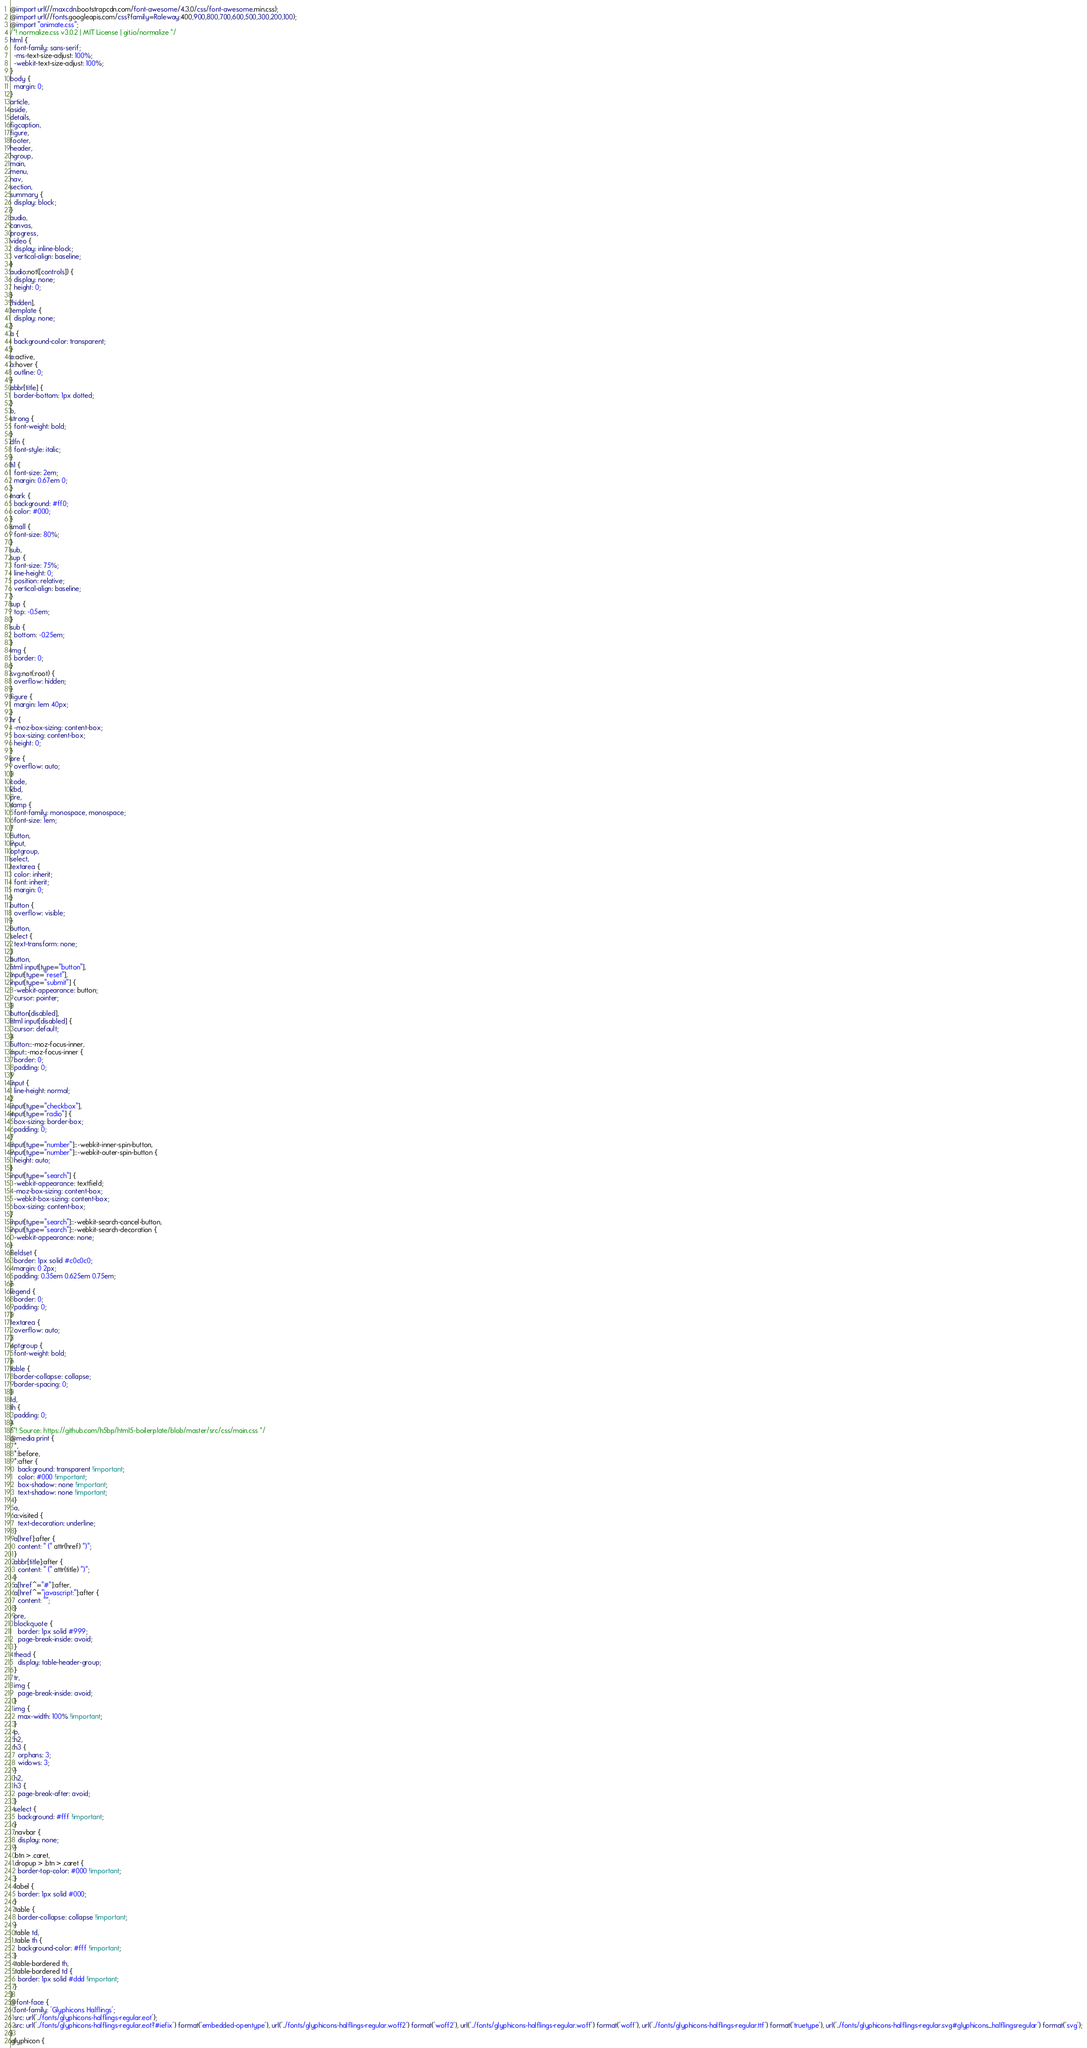Convert code to text. <code><loc_0><loc_0><loc_500><loc_500><_CSS_>@import url(//maxcdn.bootstrapcdn.com/font-awesome/4.3.0/css/font-awesome.min.css);
@import url(//fonts.googleapis.com/css?family=Raleway:400,900,800,700,600,500,300,200,100);
@import "animate.css";
/*! normalize.css v3.0.2 | MIT License | git.io/normalize */
html {
  font-family: sans-serif;
  -ms-text-size-adjust: 100%;
  -webkit-text-size-adjust: 100%;
}
body {
  margin: 0;
}
article,
aside,
details,
figcaption,
figure,
footer,
header,
hgroup,
main,
menu,
nav,
section,
summary {
  display: block;
}
audio,
canvas,
progress,
video {
  display: inline-block;
  vertical-align: baseline;
}
audio:not([controls]) {
  display: none;
  height: 0;
}
[hidden],
template {
  display: none;
}
a {
  background-color: transparent;
}
a:active,
a:hover {
  outline: 0;
}
abbr[title] {
  border-bottom: 1px dotted;
}
b,
strong {
  font-weight: bold;
}
dfn {
  font-style: italic;
}
h1 {
  font-size: 2em;
  margin: 0.67em 0;
}
mark {
  background: #ff0;
  color: #000;
}
small {
  font-size: 80%;
}
sub,
sup {
  font-size: 75%;
  line-height: 0;
  position: relative;
  vertical-align: baseline;
}
sup {
  top: -0.5em;
}
sub {
  bottom: -0.25em;
}
img {
  border: 0;
}
svg:not(:root) {
  overflow: hidden;
}
figure {
  margin: 1em 40px;
}
hr {
  -moz-box-sizing: content-box;
  box-sizing: content-box;
  height: 0;
}
pre {
  overflow: auto;
}
code,
kbd,
pre,
samp {
  font-family: monospace, monospace;
  font-size: 1em;
}
button,
input,
optgroup,
select,
textarea {
  color: inherit;
  font: inherit;
  margin: 0;
}
button {
  overflow: visible;
}
button,
select {
  text-transform: none;
}
button,
html input[type="button"],
input[type="reset"],
input[type="submit"] {
  -webkit-appearance: button;
  cursor: pointer;
}
button[disabled],
html input[disabled] {
  cursor: default;
}
button::-moz-focus-inner,
input::-moz-focus-inner {
  border: 0;
  padding: 0;
}
input {
  line-height: normal;
}
input[type="checkbox"],
input[type="radio"] {
  box-sizing: border-box;
  padding: 0;
}
input[type="number"]::-webkit-inner-spin-button,
input[type="number"]::-webkit-outer-spin-button {
  height: auto;
}
input[type="search"] {
  -webkit-appearance: textfield;
  -moz-box-sizing: content-box;
  -webkit-box-sizing: content-box;
  box-sizing: content-box;
}
input[type="search"]::-webkit-search-cancel-button,
input[type="search"]::-webkit-search-decoration {
  -webkit-appearance: none;
}
fieldset {
  border: 1px solid #c0c0c0;
  margin: 0 2px;
  padding: 0.35em 0.625em 0.75em;
}
legend {
  border: 0;
  padding: 0;
}
textarea {
  overflow: auto;
}
optgroup {
  font-weight: bold;
}
table {
  border-collapse: collapse;
  border-spacing: 0;
}
td,
th {
  padding: 0;
}
/*! Source: https://github.com/h5bp/html5-boilerplate/blob/master/src/css/main.css */
@media print {
  *,
  *:before,
  *:after {
    background: transparent !important;
    color: #000 !important;
    box-shadow: none !important;
    text-shadow: none !important;
  }
  a,
  a:visited {
    text-decoration: underline;
  }
  a[href]:after {
    content: " (" attr(href) ")";
  }
  abbr[title]:after {
    content: " (" attr(title) ")";
  }
  a[href^="#"]:after,
  a[href^="javascript:"]:after {
    content: "";
  }
  pre,
  blockquote {
    border: 1px solid #999;
    page-break-inside: avoid;
  }
  thead {
    display: table-header-group;
  }
  tr,
  img {
    page-break-inside: avoid;
  }
  img {
    max-width: 100% !important;
  }
  p,
  h2,
  h3 {
    orphans: 3;
    widows: 3;
  }
  h2,
  h3 {
    page-break-after: avoid;
  }
  select {
    background: #fff !important;
  }
  .navbar {
    display: none;
  }
  .btn > .caret,
  .dropup > .btn > .caret {
    border-top-color: #000 !important;
  }
  .label {
    border: 1px solid #000;
  }
  .table {
    border-collapse: collapse !important;
  }
  .table td,
  .table th {
    background-color: #fff !important;
  }
  .table-bordered th,
  .table-bordered td {
    border: 1px solid #ddd !important;
  }
}
@font-face {
  font-family: 'Glyphicons Halflings';
  src: url('../fonts/glyphicons-halflings-regular.eot');
  src: url('../fonts/glyphicons-halflings-regular.eot?#iefix') format('embedded-opentype'), url('../fonts/glyphicons-halflings-regular.woff2') format('woff2'), url('../fonts/glyphicons-halflings-regular.woff') format('woff'), url('../fonts/glyphicons-halflings-regular.ttf') format('truetype'), url('../fonts/glyphicons-halflings-regular.svg#glyphicons_halflingsregular') format('svg');
}
.glyphicon {</code> 